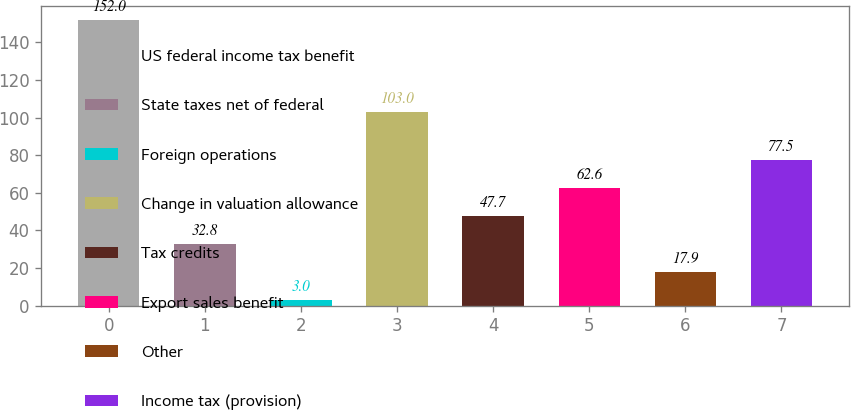Convert chart. <chart><loc_0><loc_0><loc_500><loc_500><bar_chart><fcel>US federal income tax benefit<fcel>State taxes net of federal<fcel>Foreign operations<fcel>Change in valuation allowance<fcel>Tax credits<fcel>Export sales benefit<fcel>Other<fcel>Income tax (provision)<nl><fcel>152<fcel>32.8<fcel>3<fcel>103<fcel>47.7<fcel>62.6<fcel>17.9<fcel>77.5<nl></chart> 